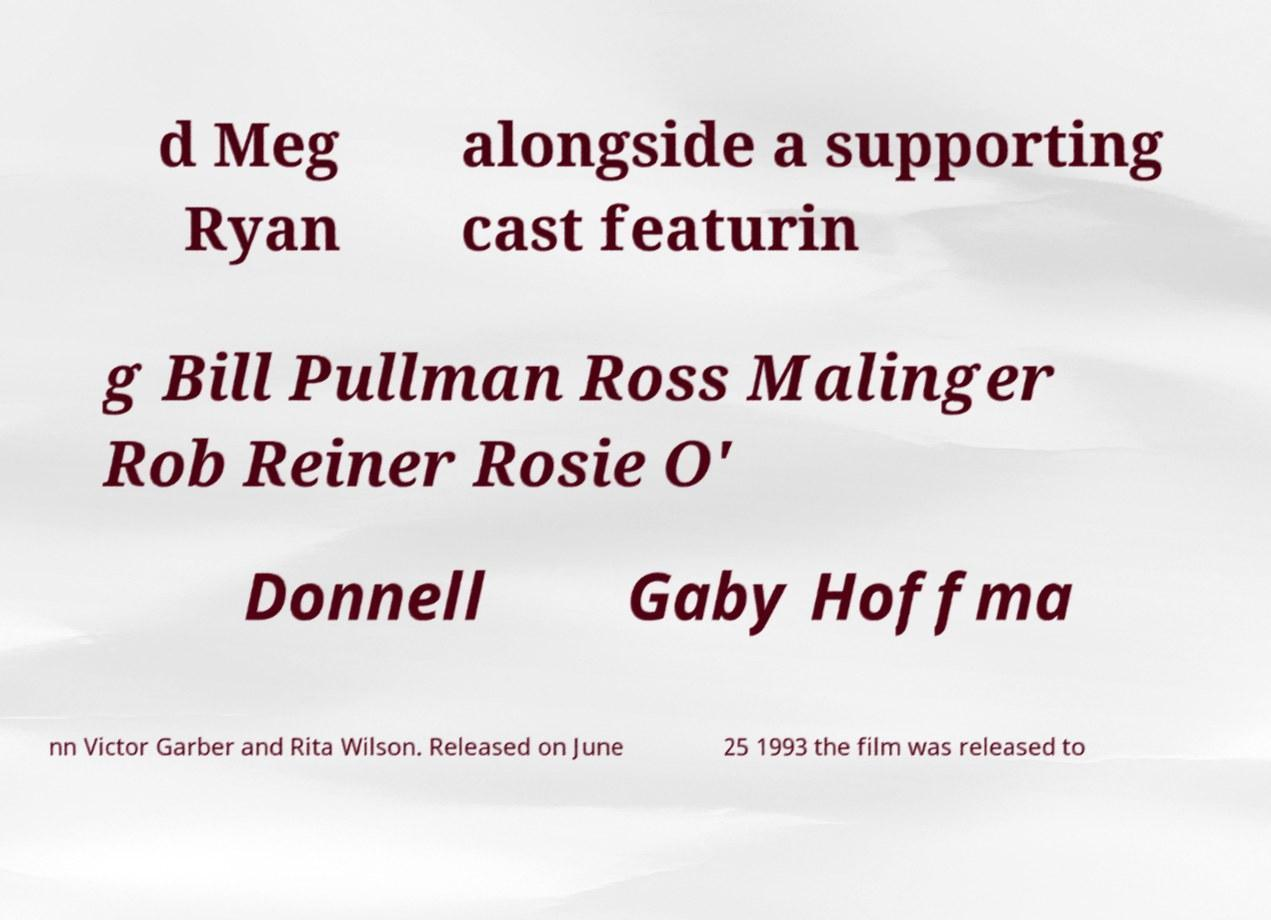Could you extract and type out the text from this image? d Meg Ryan alongside a supporting cast featurin g Bill Pullman Ross Malinger Rob Reiner Rosie O' Donnell Gaby Hoffma nn Victor Garber and Rita Wilson. Released on June 25 1993 the film was released to 